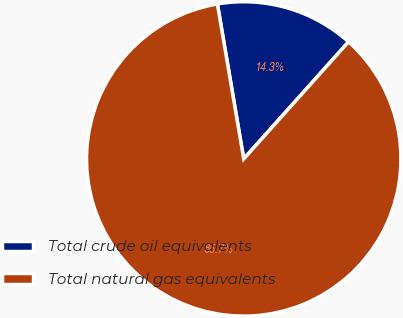<chart> <loc_0><loc_0><loc_500><loc_500><pie_chart><fcel>Total crude oil equivalents<fcel>Total natural gas equivalents<nl><fcel>14.3%<fcel>85.7%<nl></chart> 